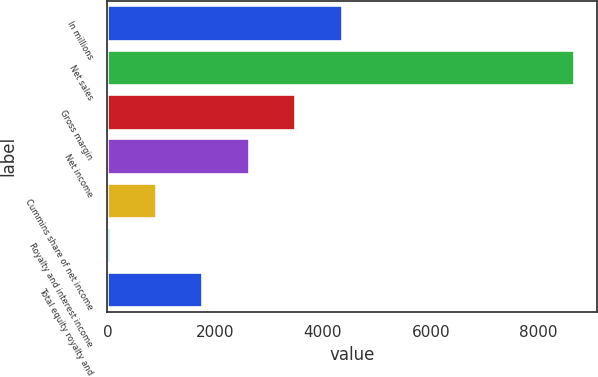Convert chart to OTSL. <chart><loc_0><loc_0><loc_500><loc_500><bar_chart><fcel>In millions<fcel>Net sales<fcel>Gross margin<fcel>Net income<fcel>Cummins share of net income<fcel>Royalty and interest income<fcel>Total equity royalty and<nl><fcel>4350<fcel>8659<fcel>3488.2<fcel>2626.4<fcel>902.8<fcel>41<fcel>1764.6<nl></chart> 